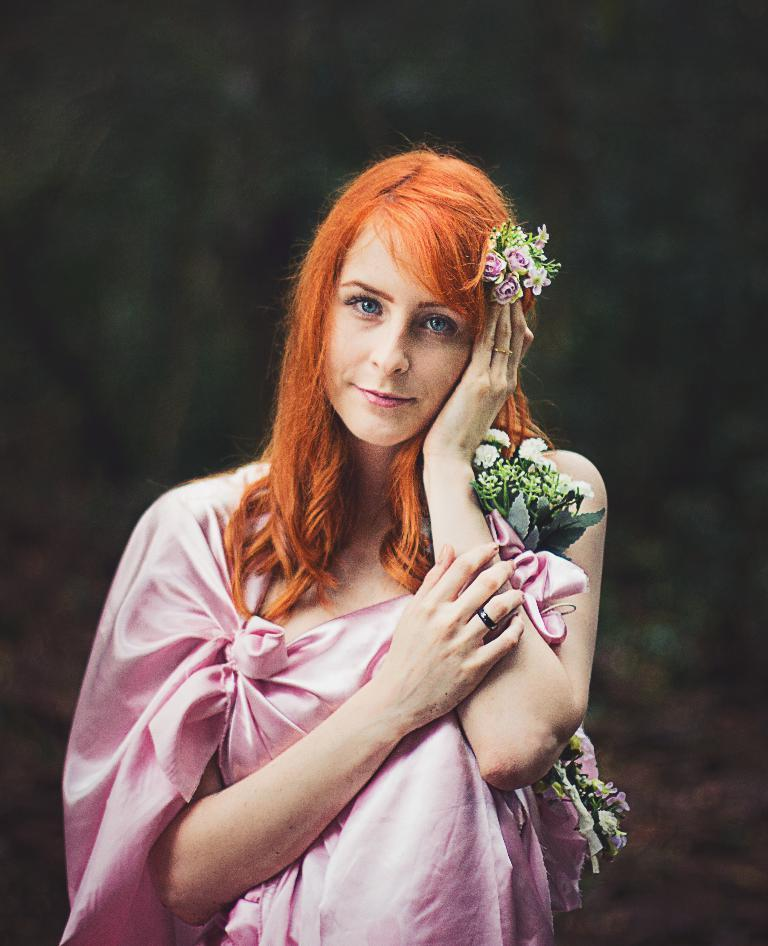Who is the main subject in the image? There is a woman in the image. What is the woman wearing? The woman is wearing a pink dress. What is the woman holding in the image? The woman is holding flowers. Can you describe the background of the image? The background of the image is blurry. What type of mine is visible in the background of the image? There is no mine visible in the background of the image. What is the woman doing at work in the image? The image does not show the woman at work, nor does it provide any context about her occupation. 